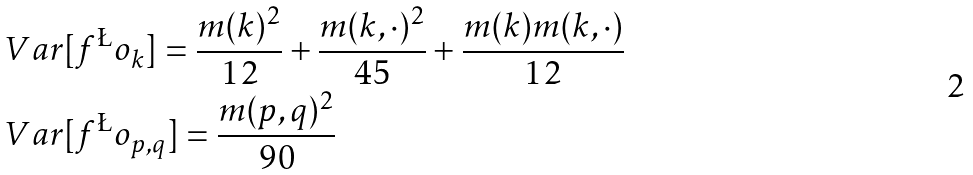<formula> <loc_0><loc_0><loc_500><loc_500>& \ V a r [ f ^ { \L } o _ { k } ] = \frac { m ( k ) ^ { 2 } } { 1 2 } + \frac { m ( k , \cdot ) ^ { 2 } } { 4 5 } + \frac { m ( k ) m ( k , \cdot ) } { 1 2 } \\ & \ V a r [ f ^ { \L } o _ { p , q } ] = \frac { m ( p , q ) ^ { 2 } } { 9 0 }</formula> 